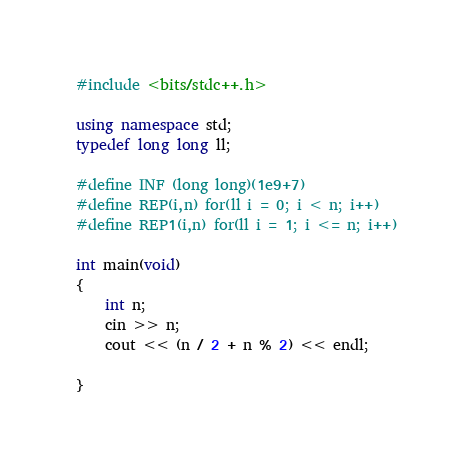<code> <loc_0><loc_0><loc_500><loc_500><_C++_>#include <bits/stdc++.h>

using namespace std;
typedef long long ll;

#define INF (long long)(1e9+7)
#define REP(i,n) for(ll i = 0; i < n; i++)
#define REP1(i,n) for(ll i = 1; i <= n; i++)

int main(void)
{
    int n;
    cin >> n;
    cout << (n / 2 + n % 2) << endl;

}
</code> 